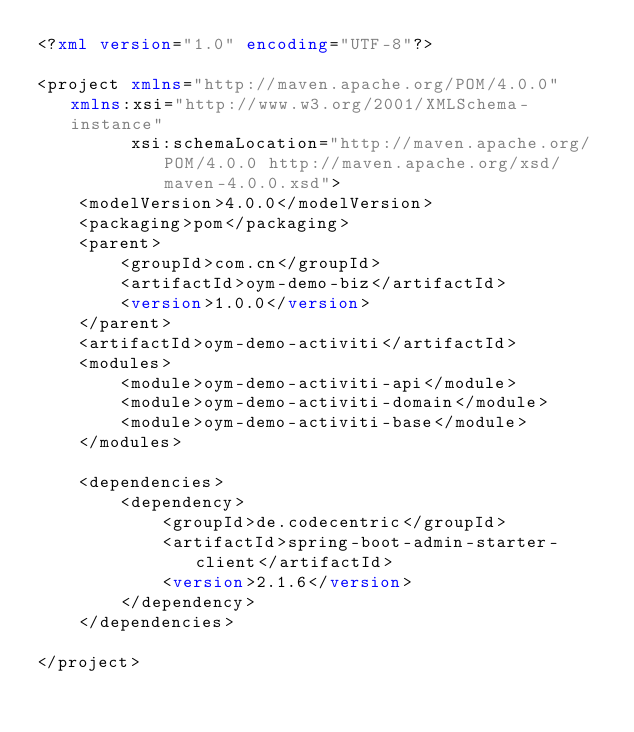Convert code to text. <code><loc_0><loc_0><loc_500><loc_500><_XML_><?xml version="1.0" encoding="UTF-8"?>

<project xmlns="http://maven.apache.org/POM/4.0.0" xmlns:xsi="http://www.w3.org/2001/XMLSchema-instance"
         xsi:schemaLocation="http://maven.apache.org/POM/4.0.0 http://maven.apache.org/xsd/maven-4.0.0.xsd">
    <modelVersion>4.0.0</modelVersion>
    <packaging>pom</packaging>
    <parent>
        <groupId>com.cn</groupId>
        <artifactId>oym-demo-biz</artifactId>
        <version>1.0.0</version>
    </parent>
    <artifactId>oym-demo-activiti</artifactId>
    <modules>
        <module>oym-demo-activiti-api</module>
        <module>oym-demo-activiti-domain</module>
        <module>oym-demo-activiti-base</module>
    </modules>

    <dependencies>
        <dependency>
            <groupId>de.codecentric</groupId>
            <artifactId>spring-boot-admin-starter-client</artifactId>
            <version>2.1.6</version>
        </dependency>
    </dependencies>

</project>
</code> 